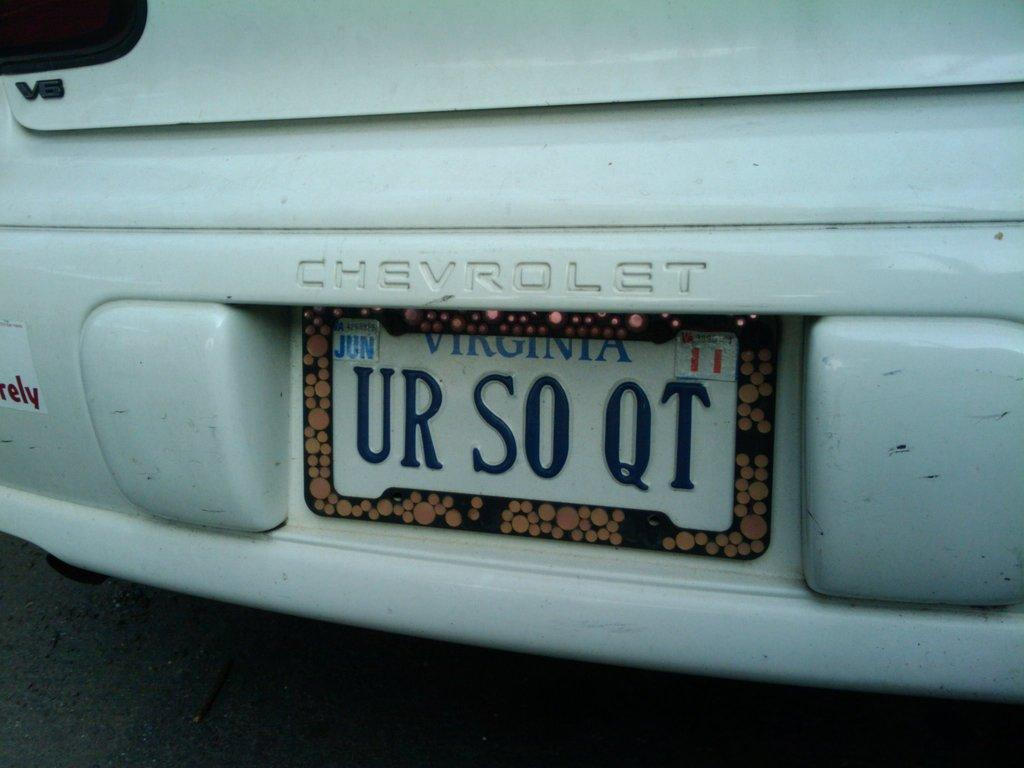<image>
Relay a brief, clear account of the picture shown. a chevrolet car has a license plate that says UR SO QT 